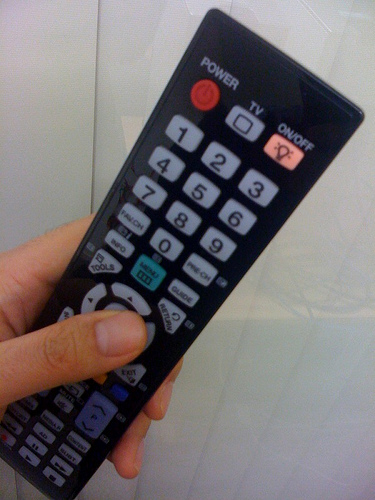Identify the text displayed in this image. POWER TV ON/OFF TOOLS 0 7 9 8 5 4 6 3 2 1 